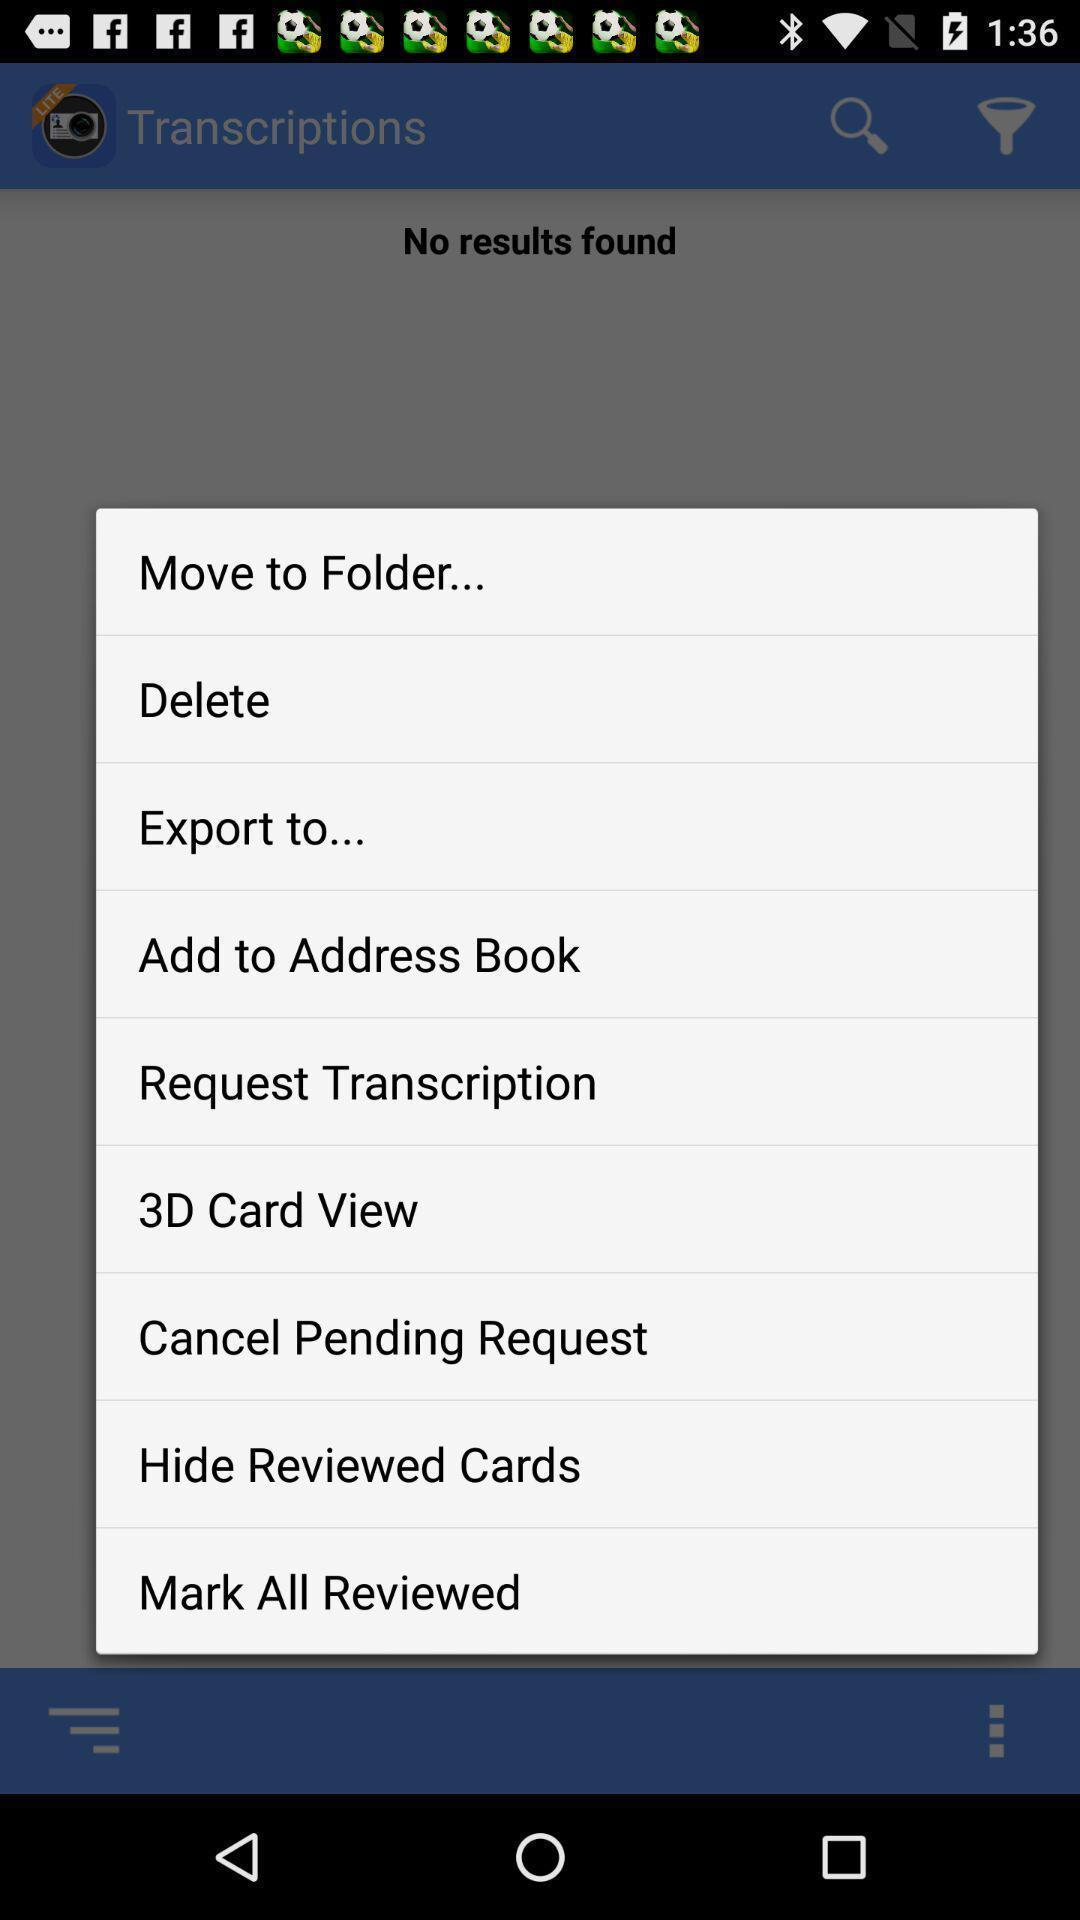What is the overall content of this screenshot? Pop up showing different options on an app. 